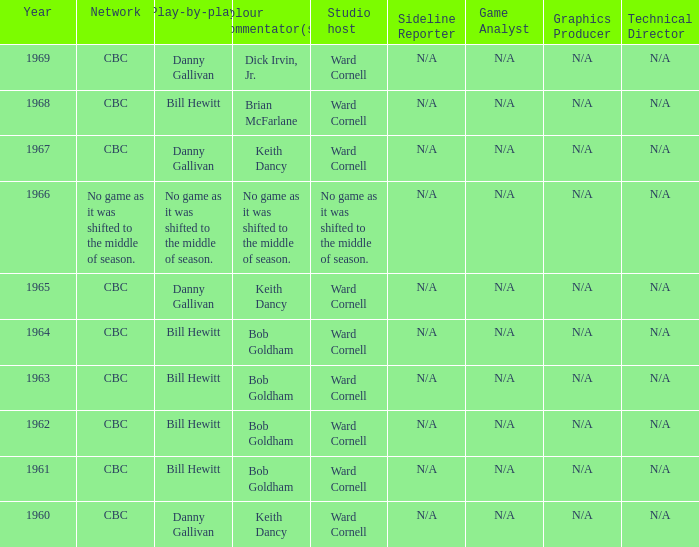Who did the play-by-play on the CBC network before 1961? Danny Gallivan. Write the full table. {'header': ['Year', 'Network', 'Play-by-play', 'Colour commentator(s)', 'Studio host', 'Sideline Reporter', 'Game Analyst', 'Graphics Producer', 'Technical Director'], 'rows': [['1969', 'CBC', 'Danny Gallivan', 'Dick Irvin, Jr.', 'Ward Cornell', 'N/A', 'N/A', 'N/A', 'N/A'], ['1968', 'CBC', 'Bill Hewitt', 'Brian McFarlane', 'Ward Cornell', 'N/A', 'N/A', 'N/A', 'N/A'], ['1967', 'CBC', 'Danny Gallivan', 'Keith Dancy', 'Ward Cornell', 'N/A', 'N/A', 'N/A', 'N/A'], ['1966', 'No game as it was shifted to the middle of season.', 'No game as it was shifted to the middle of season.', 'No game as it was shifted to the middle of season.', 'No game as it was shifted to the middle of season.', 'N/A', 'N/A', 'N/A', 'N/A'], ['1965', 'CBC', 'Danny Gallivan', 'Keith Dancy', 'Ward Cornell', 'N/A', 'N/A', 'N/A', 'N/A'], ['1964', 'CBC', 'Bill Hewitt', 'Bob Goldham', 'Ward Cornell', 'N/A', 'N/A', 'N/A', 'N/A'], ['1963', 'CBC', 'Bill Hewitt', 'Bob Goldham', 'Ward Cornell', 'N/A', 'N/A', 'N/A', 'N/A'], ['1962', 'CBC', 'Bill Hewitt', 'Bob Goldham', 'Ward Cornell', 'N/A', 'N/A', 'N/A', 'N/A'], ['1961', 'CBC', 'Bill Hewitt', 'Bob Goldham', 'Ward Cornell', 'N/A', 'N/A', 'N/A', 'N/A'], ['1960', 'CBC', 'Danny Gallivan', 'Keith Dancy', 'Ward Cornell', 'N/A', 'N/A', 'N/A', 'N/A']]} 